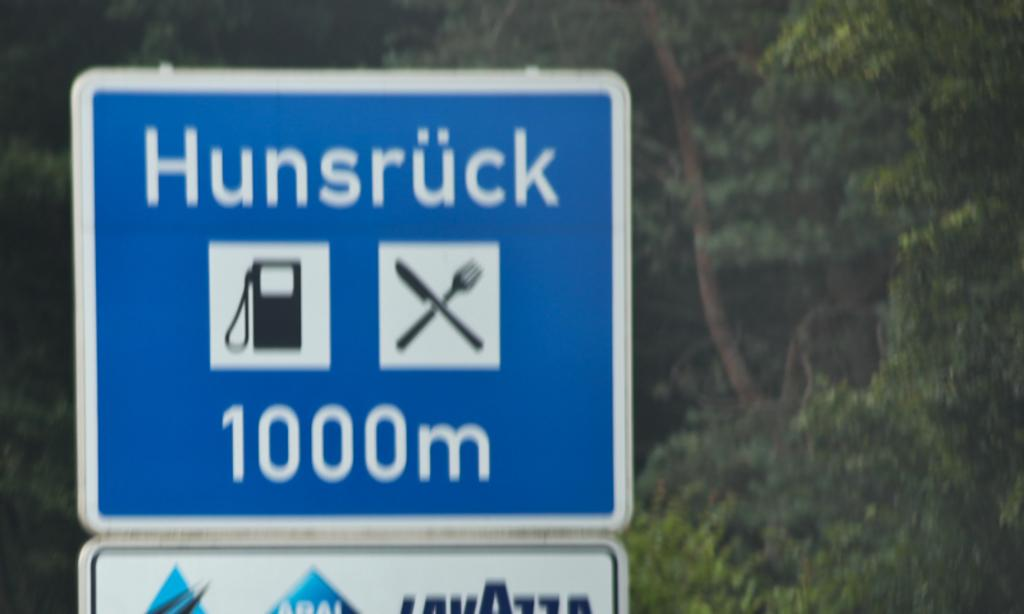<image>
Present a compact description of the photo's key features. A blue sign shows a gas station logo and a fork and says Hunsruck 1000m. 